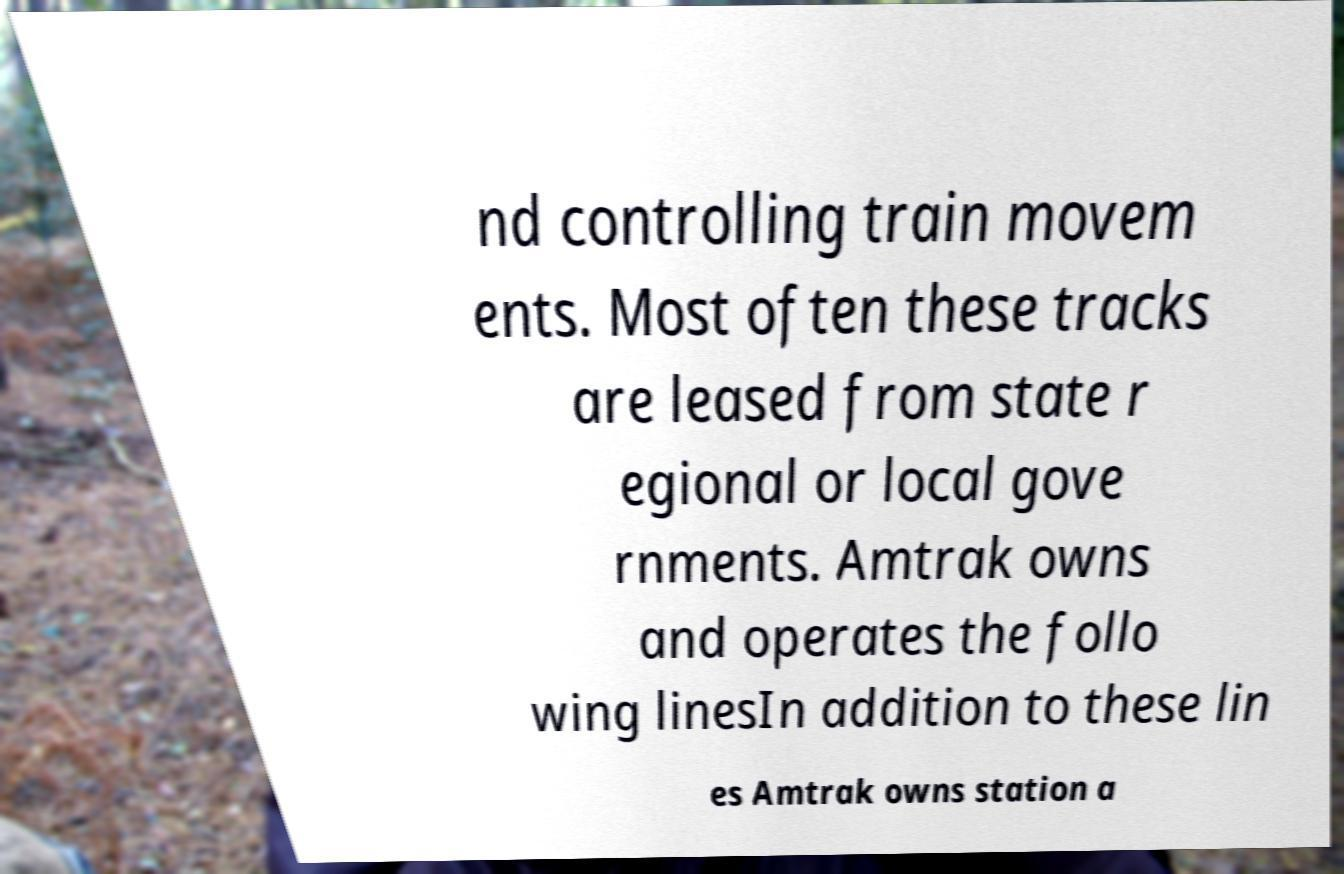Could you extract and type out the text from this image? nd controlling train movem ents. Most often these tracks are leased from state r egional or local gove rnments. Amtrak owns and operates the follo wing linesIn addition to these lin es Amtrak owns station a 